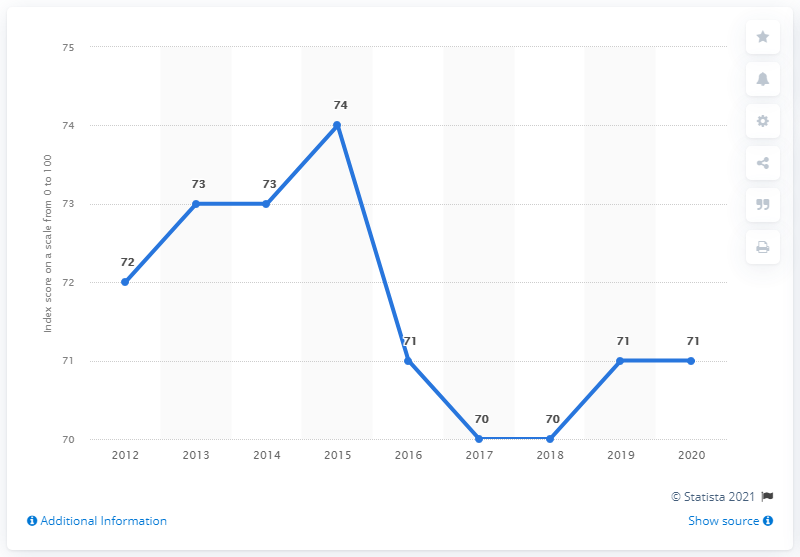Specify some key components in this picture. In 2019 and 2020, Uruguay's corruption perception index score was 71. 